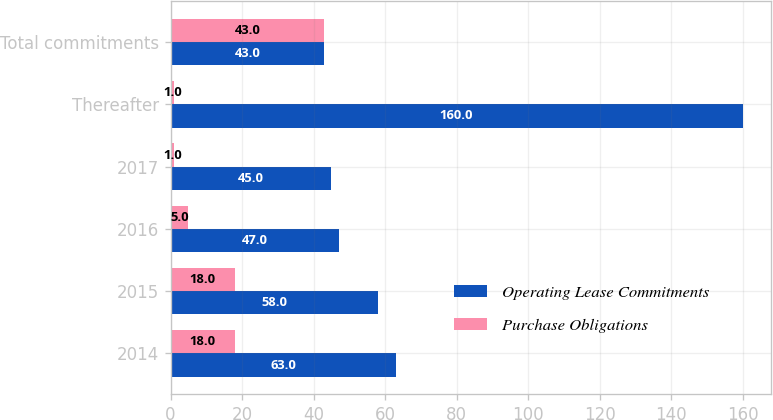<chart> <loc_0><loc_0><loc_500><loc_500><stacked_bar_chart><ecel><fcel>2014<fcel>2015<fcel>2016<fcel>2017<fcel>Thereafter<fcel>Total commitments<nl><fcel>Operating Lease Commitments<fcel>63<fcel>58<fcel>47<fcel>45<fcel>160<fcel>43<nl><fcel>Purchase Obligations<fcel>18<fcel>18<fcel>5<fcel>1<fcel>1<fcel>43<nl></chart> 